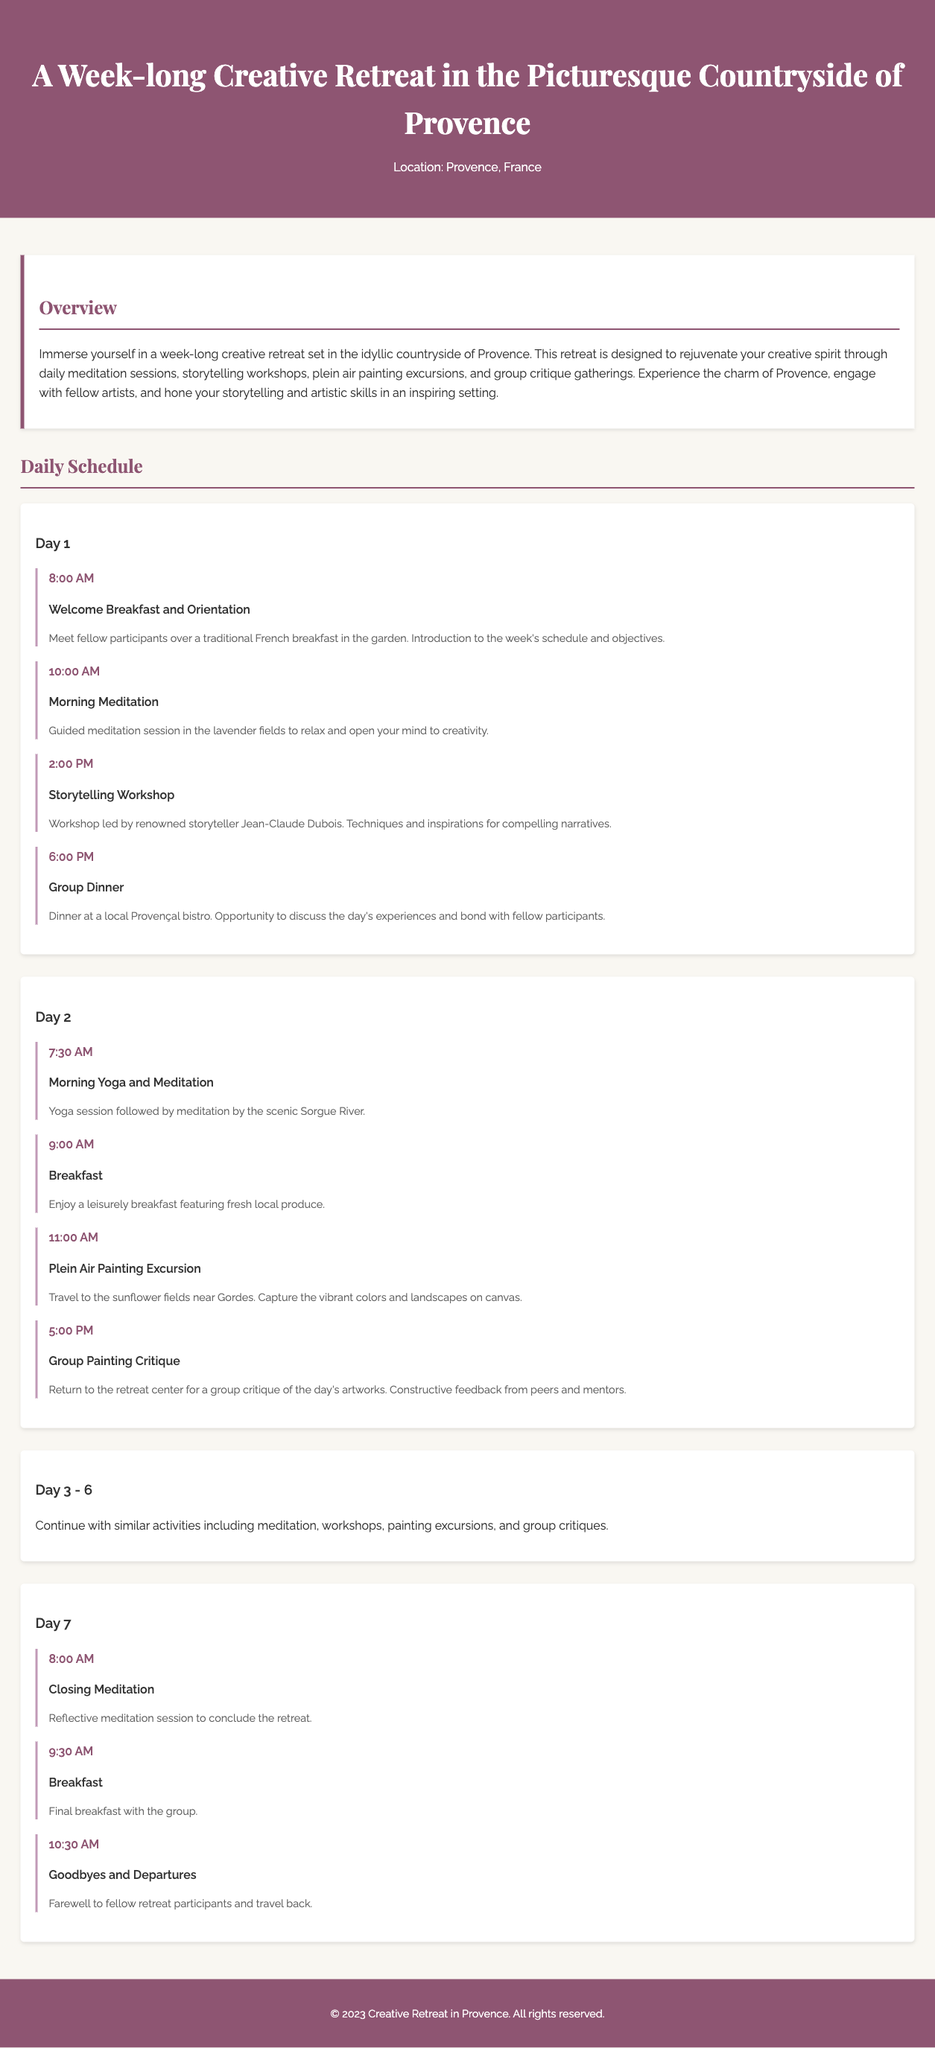what is the location of the retreat? The location of the retreat is stated at the top of the document.
Answer: Provence, France who leads the storytelling workshop? The document specifies who conducts the workshop in the Day 1 schedule.
Answer: Jean-Claude Dubois how many days does the retreat last? The document outlines the duration of the retreat in the overview section.
Answer: 7 days what activity starts at 8:00 AM on Day 7? The specific time for activities is mentioned in the Day 7 schedule.
Answer: Closing Meditation what type of feedback is provided during the group critique? The nature of feedback is described in the context of the group painting critique activity.
Answer: Constructive feedback what is a common activity throughout the retreat? The document indicates activities that are regularly scheduled during the week.
Answer: Meditation when does the group dinner take place on Day 1? The specific time for dinner is listed in the Day 1 schedule.
Answer: 6:00 PM where is the plein air painting excursion on Day 2? The document specifies the location for the painting excursion in Day 2's schedule.
Answer: Sunflower fields near Gordes what is the title of the overview section? The document includes a clear title for the overview section in the itinerary.
Answer: Overview 